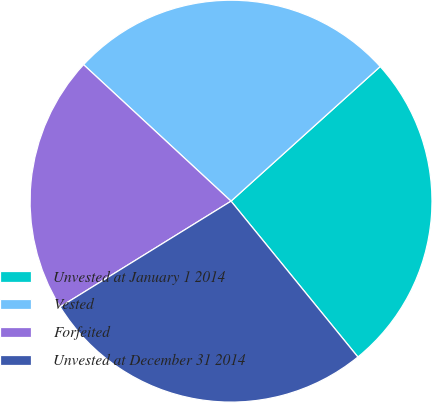Convert chart. <chart><loc_0><loc_0><loc_500><loc_500><pie_chart><fcel>Unvested at January 1 2014<fcel>Vested<fcel>Forfeited<fcel>Unvested at December 31 2014<nl><fcel>25.81%<fcel>26.43%<fcel>20.7%<fcel>27.06%<nl></chart> 